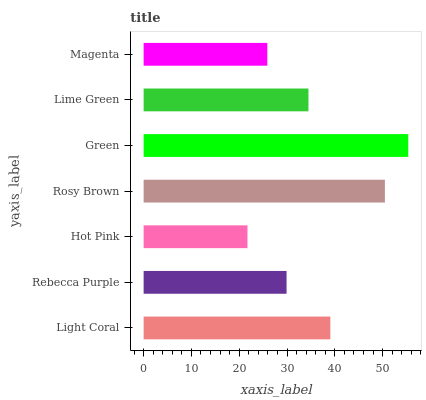Is Hot Pink the minimum?
Answer yes or no. Yes. Is Green the maximum?
Answer yes or no. Yes. Is Rebecca Purple the minimum?
Answer yes or no. No. Is Rebecca Purple the maximum?
Answer yes or no. No. Is Light Coral greater than Rebecca Purple?
Answer yes or no. Yes. Is Rebecca Purple less than Light Coral?
Answer yes or no. Yes. Is Rebecca Purple greater than Light Coral?
Answer yes or no. No. Is Light Coral less than Rebecca Purple?
Answer yes or no. No. Is Lime Green the high median?
Answer yes or no. Yes. Is Lime Green the low median?
Answer yes or no. Yes. Is Light Coral the high median?
Answer yes or no. No. Is Magenta the low median?
Answer yes or no. No. 